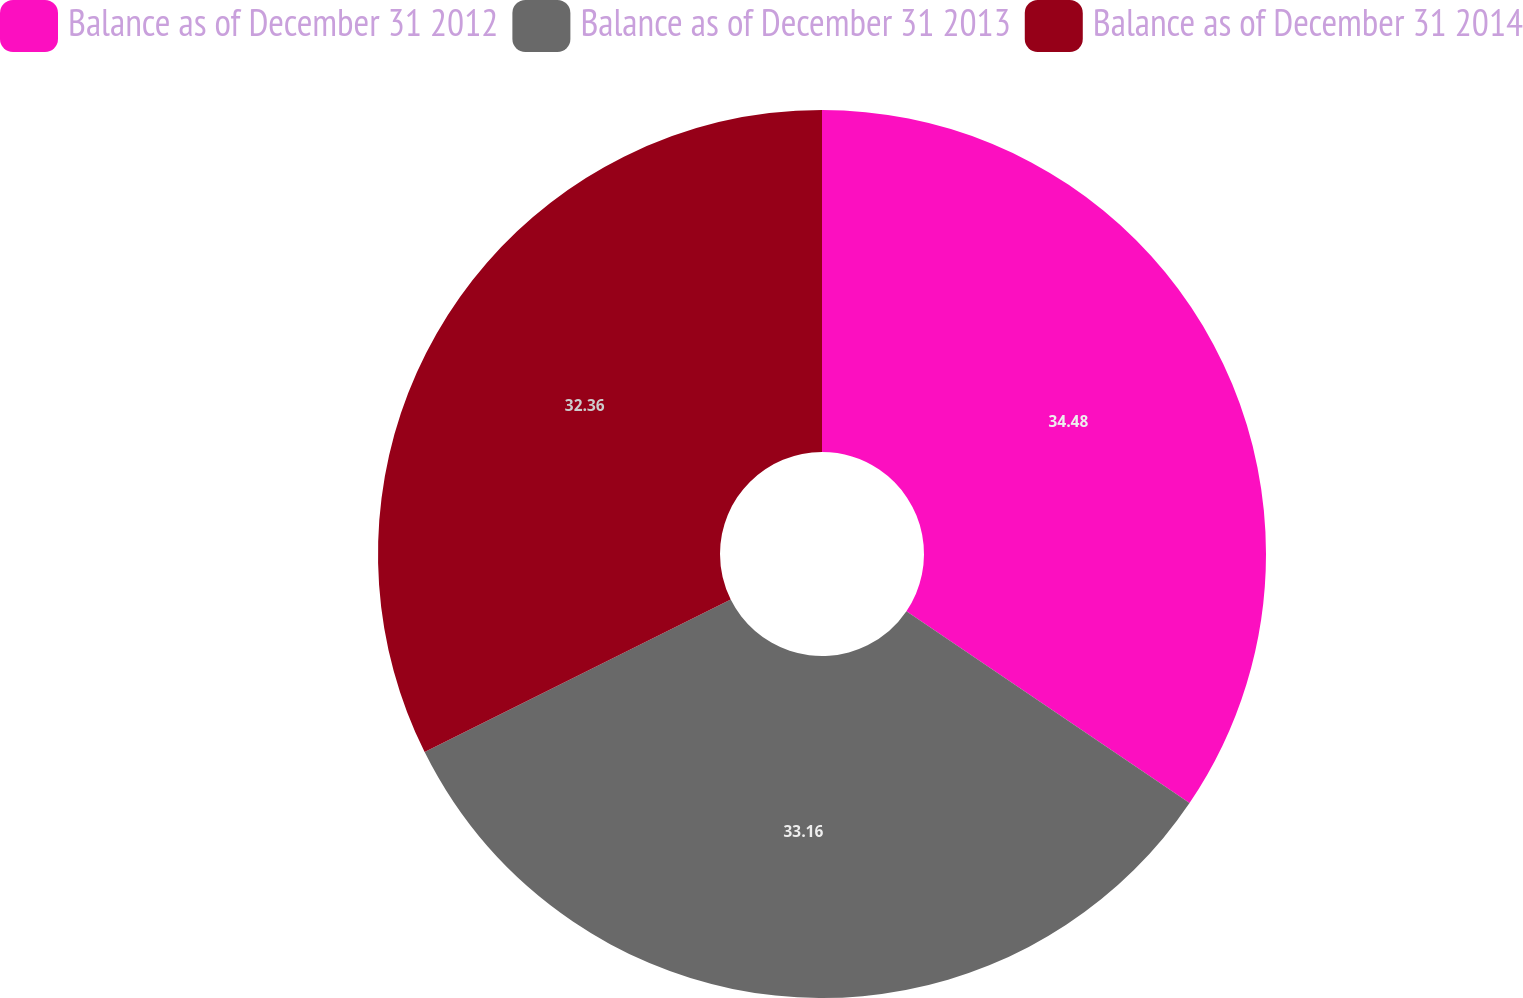Convert chart to OTSL. <chart><loc_0><loc_0><loc_500><loc_500><pie_chart><fcel>Balance as of December 31 2012<fcel>Balance as of December 31 2013<fcel>Balance as of December 31 2014<nl><fcel>34.48%<fcel>33.16%<fcel>32.36%<nl></chart> 